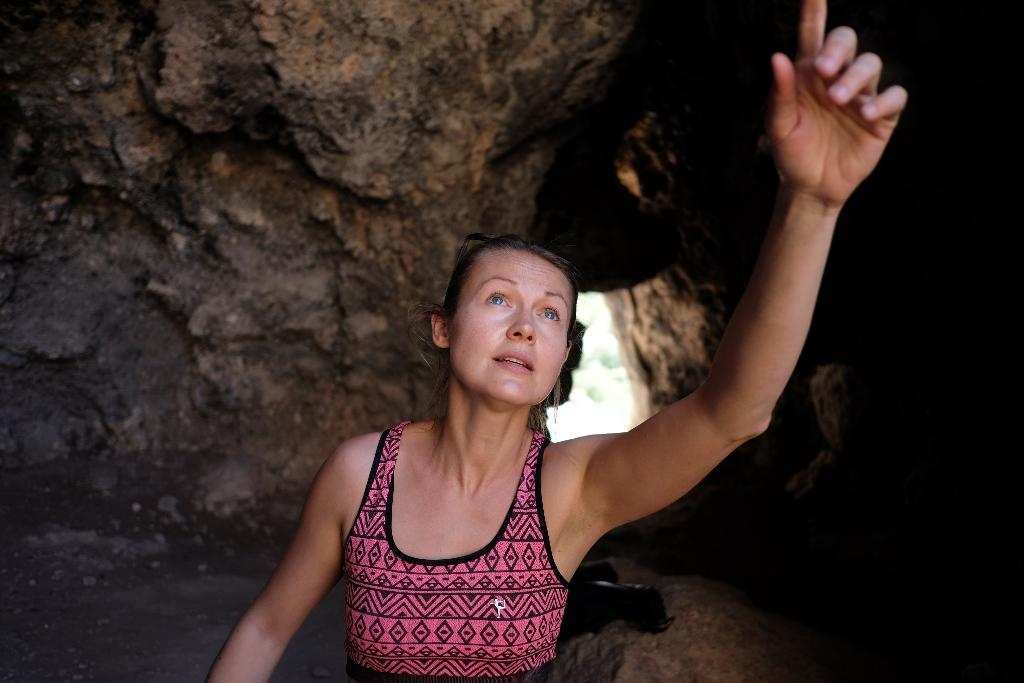Who is the main subject in the foreground of the image? There is a woman in the foreground of the image. What is the woman doing in the image? The woman is looking at someone. What can be seen in the background of the image? There is a cave in the background of the image. How many spiders are crawling on the woman's arm in the image? There are no spiders visible on the woman's arm in the image. Is there a fire burning inside the cave in the image? The image does not show any fire inside the cave, only the cave itself is visible. 